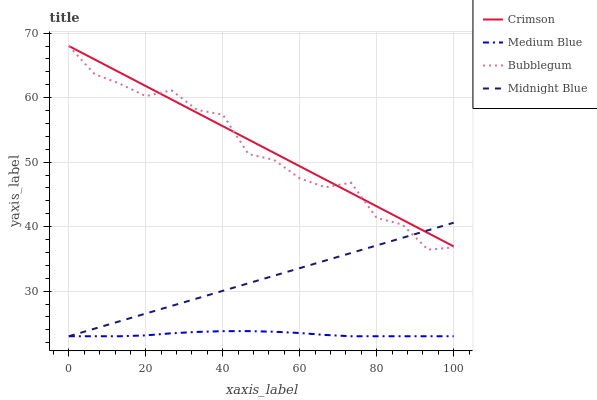Does Medium Blue have the minimum area under the curve?
Answer yes or no. Yes. Does Crimson have the maximum area under the curve?
Answer yes or no. Yes. Does Midnight Blue have the minimum area under the curve?
Answer yes or no. No. Does Midnight Blue have the maximum area under the curve?
Answer yes or no. No. Is Midnight Blue the smoothest?
Answer yes or no. Yes. Is Bubblegum the roughest?
Answer yes or no. Yes. Is Medium Blue the smoothest?
Answer yes or no. No. Is Medium Blue the roughest?
Answer yes or no. No. Does Medium Blue have the lowest value?
Answer yes or no. Yes. Does Bubblegum have the lowest value?
Answer yes or no. No. Does Bubblegum have the highest value?
Answer yes or no. Yes. Does Midnight Blue have the highest value?
Answer yes or no. No. Is Medium Blue less than Bubblegum?
Answer yes or no. Yes. Is Crimson greater than Medium Blue?
Answer yes or no. Yes. Does Crimson intersect Midnight Blue?
Answer yes or no. Yes. Is Crimson less than Midnight Blue?
Answer yes or no. No. Is Crimson greater than Midnight Blue?
Answer yes or no. No. Does Medium Blue intersect Bubblegum?
Answer yes or no. No. 